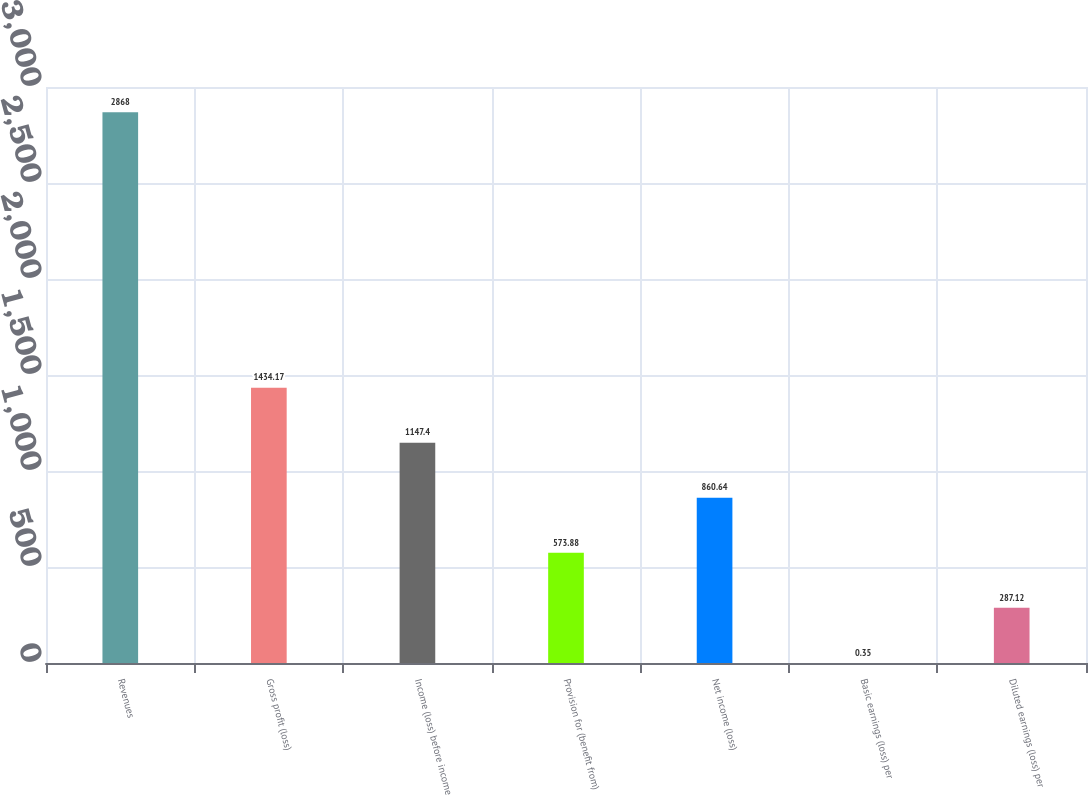Convert chart. <chart><loc_0><loc_0><loc_500><loc_500><bar_chart><fcel>Revenues<fcel>Gross profit (loss)<fcel>Income (loss) before income<fcel>Provision for (benefit from)<fcel>Net income (loss)<fcel>Basic earnings (loss) per<fcel>Diluted earnings (loss) per<nl><fcel>2868<fcel>1434.17<fcel>1147.4<fcel>573.88<fcel>860.64<fcel>0.35<fcel>287.12<nl></chart> 